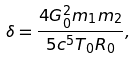Convert formula to latex. <formula><loc_0><loc_0><loc_500><loc_500>\delta = \frac { 4 G _ { 0 } ^ { 2 } m _ { 1 } m _ { 2 } } { 5 c ^ { 5 } T _ { 0 } R _ { 0 } } ,</formula> 